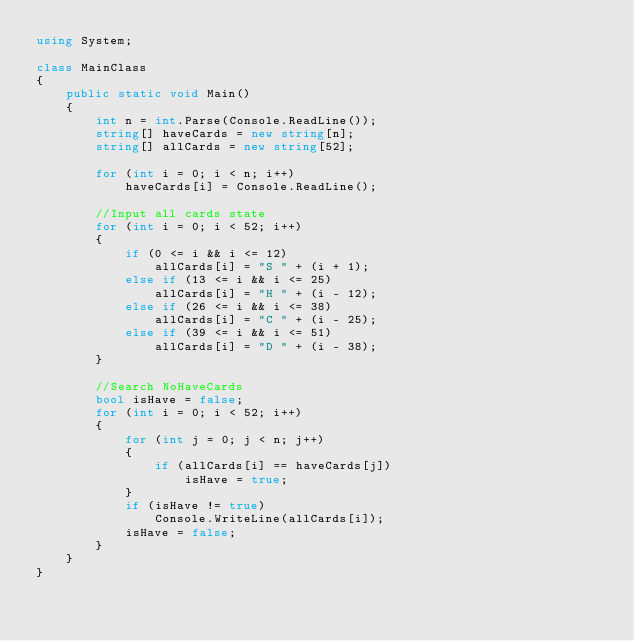Convert code to text. <code><loc_0><loc_0><loc_500><loc_500><_C#_>using System;

class MainClass
{
    public static void Main()
    {
        int n = int.Parse(Console.ReadLine());
        string[] haveCards = new string[n];
        string[] allCards = new string[52];

        for (int i = 0; i < n; i++)
            haveCards[i] = Console.ReadLine();

        //Input all cards state
        for (int i = 0; i < 52; i++)
        {
            if (0 <= i && i <= 12)
                allCards[i] = "S " + (i + 1);
            else if (13 <= i && i <= 25)
                allCards[i] = "H " + (i - 12);
            else if (26 <= i && i <= 38)
                allCards[i] = "C " + (i - 25);
            else if (39 <= i && i <= 51)
                allCards[i] = "D " + (i - 38);
        }

        //Search NoHaveCards
        bool isHave = false;
        for (int i = 0; i < 52; i++)
        {
            for (int j = 0; j < n; j++)
            {
                if (allCards[i] == haveCards[j])
                    isHave = true;
            }
            if (isHave != true)
                Console.WriteLine(allCards[i]);
            isHave = false;
        }
    }
}</code> 